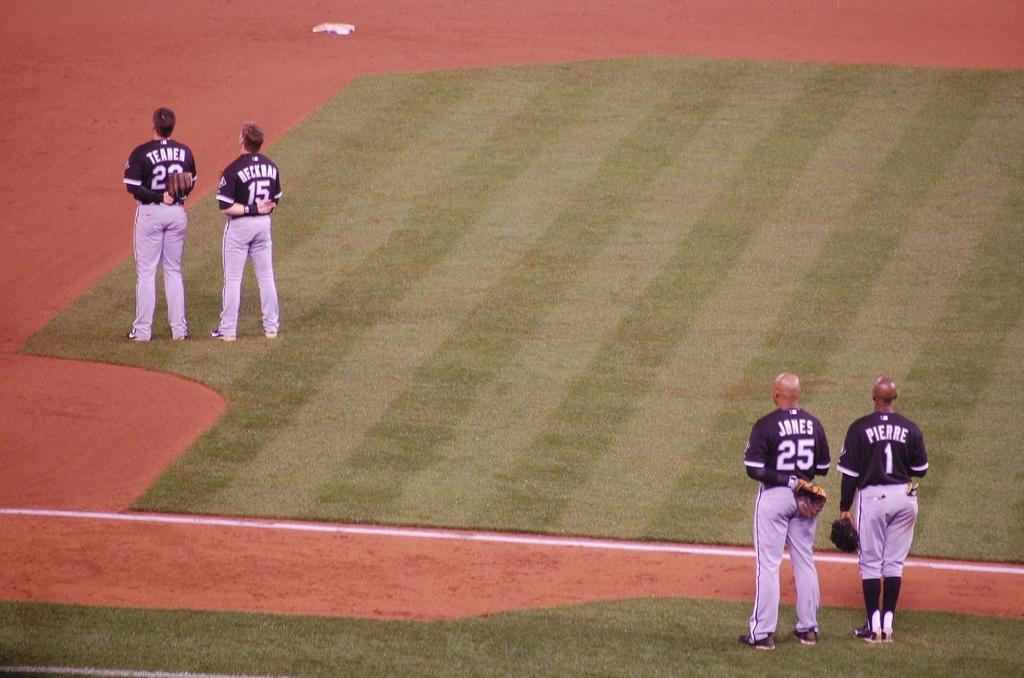<image>
Present a compact description of the photo's key features. Baseball player wearing number 25 standing to one wearing number 1. 